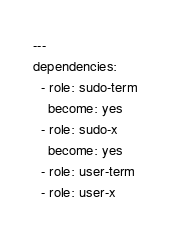Convert code to text. <code><loc_0><loc_0><loc_500><loc_500><_YAML_>---
dependencies:
  - role: sudo-term
    become: yes
  - role: sudo-x
    become: yes
  - role: user-term
  - role: user-x
</code> 